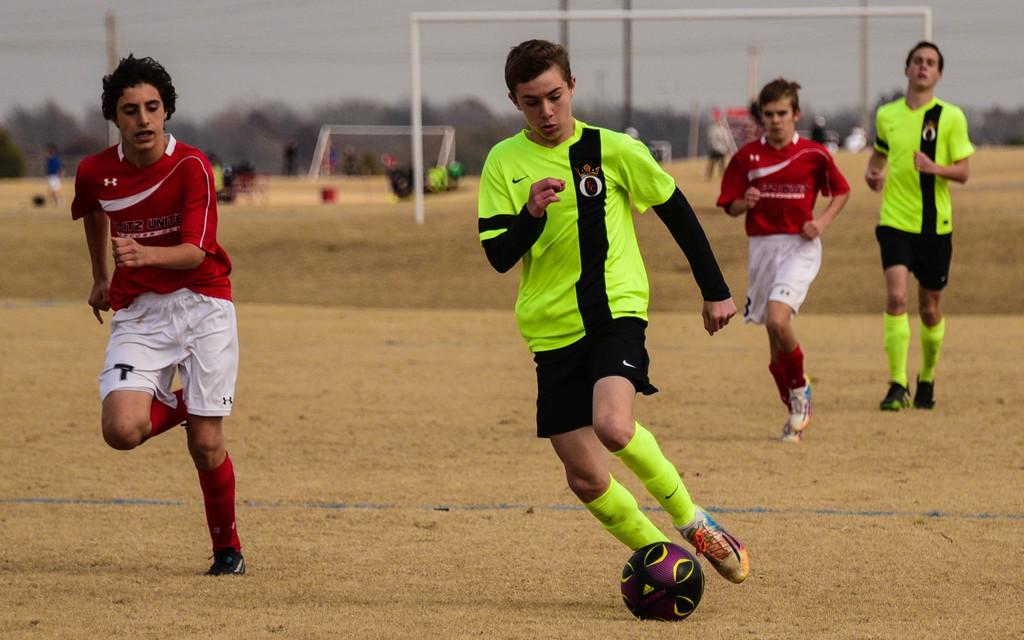Who or what can be seen in the image? There are people in the image. What are the people doing in the image? The people are standing on the ground and playing with a football. What are the people wearing in the image? The people are wearing uniforms. What type of ear can be seen on the football in the image? There is no ear present on the football in the image, as footballs do not have ears. 